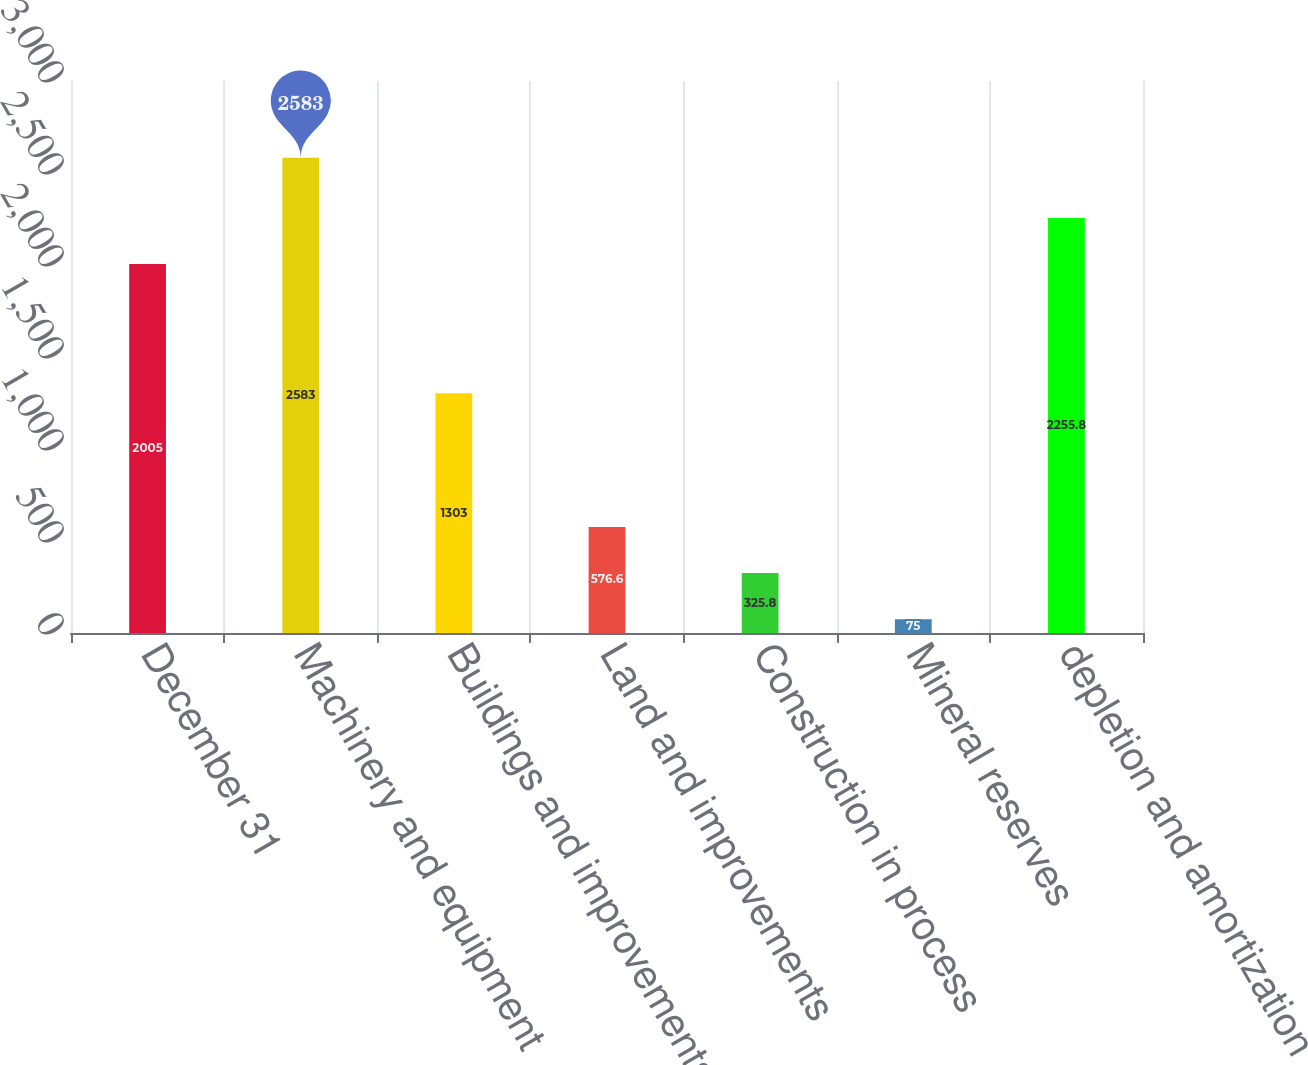Convert chart to OTSL. <chart><loc_0><loc_0><loc_500><loc_500><bar_chart><fcel>December 31<fcel>Machinery and equipment<fcel>Buildings and improvements<fcel>Land and improvements<fcel>Construction in process<fcel>Mineral reserves<fcel>depletion and amortization<nl><fcel>2005<fcel>2583<fcel>1303<fcel>576.6<fcel>325.8<fcel>75<fcel>2255.8<nl></chart> 